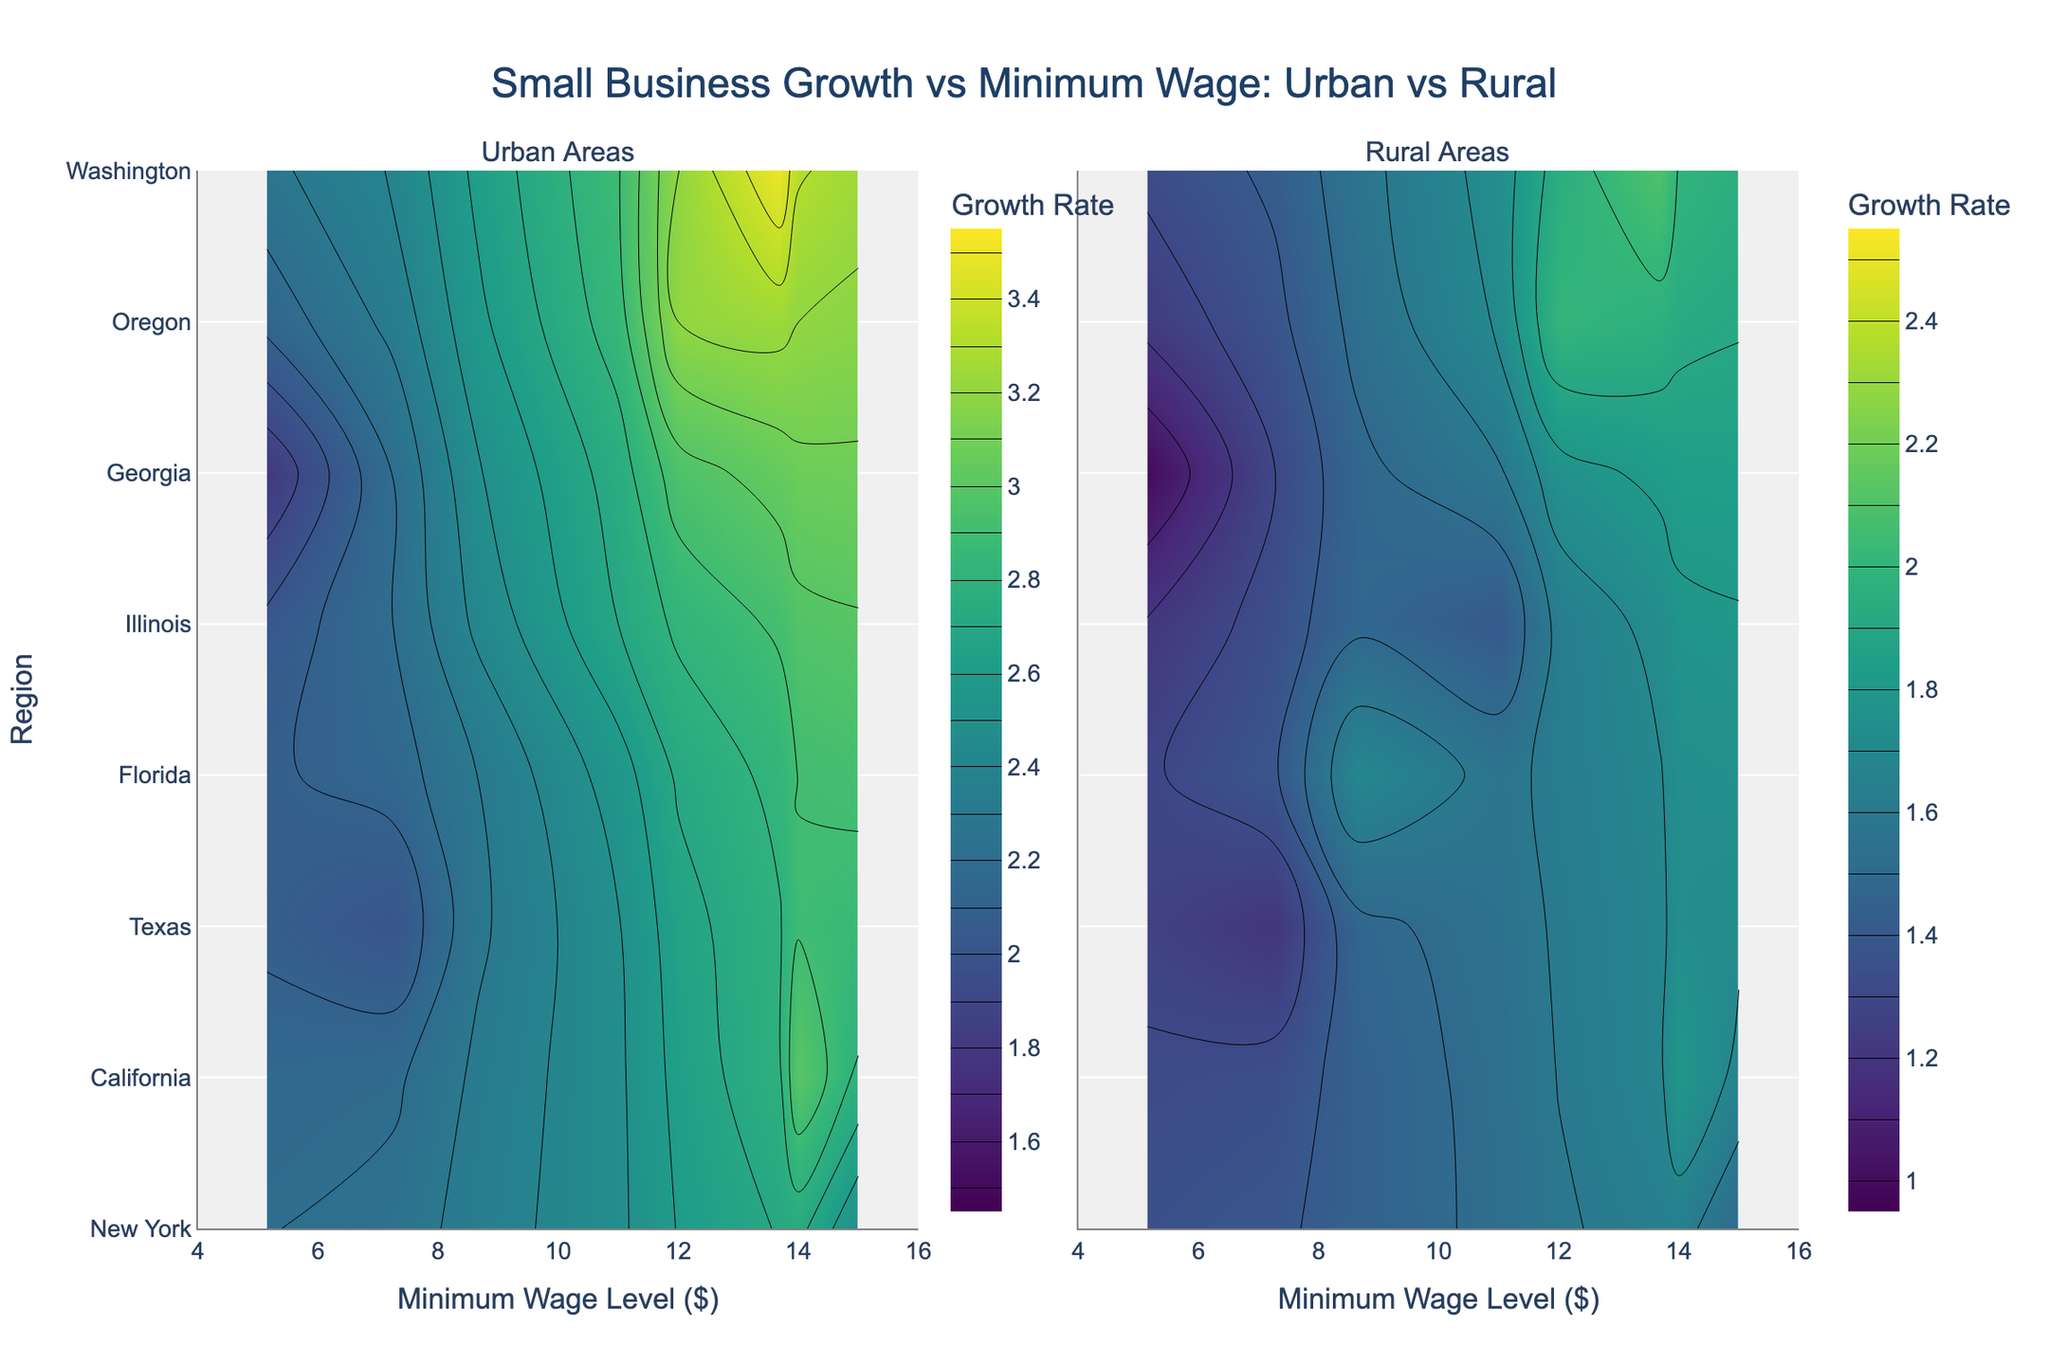What is the title of the figure? The title is located at the top center of the figure, visually distinguishing itself from the rest of the content and provides a summary of what the figure represents.
Answer: Small Business Growth vs Minimum Wage: Urban vs Rural What does the y-axis represent? The y-axis on both subplots lists different regions, as indicated by the labels along the vertical axis on the left side.
Answer: Region How many subplots are in the figure? The figure is divided into two separate parts side by side, indicating the usage of subplots.
Answer: Two Which region shows the highest growth in urban areas? To determine this, check the highest growth rate value among urban areas, which is indicated by the contour colors and labels.
Answer: Washington What is the range of minimum wage levels shown in this figure? The minimum wage levels are represented along the x-axis, and the range can be determined by noting the lowest and highest values.
Answer: $5.15 to $15 Is the growth in rural areas generally higher or lower than in urban areas? Comparing the general height of contour levels between the two subplots provides insight into this question.
Answer: Lower Which region has the smallest business growth rate in rural areas? The rural subplot shows the contour with the lowest growth rate, which is listed near a specific region.
Answer: Georgia How does the small business growth in New York's urban area compare to its rural area? By comparing the contours for New York in both subplots, differences in growth between urban and rural areas can be assessed.
Answer: New York's urban (2.5) is higher than rural (1.5) What's the difference in small business growth between urban and rural areas in California? Identify the growth rates for California in both subplots and subtract the rural value from the urban value.
Answer: 1.2 (3.0 - 1.8) Which area type shows more variation in small business growth rates? By observing the spread and variation in contour levels across both subplots, the variation in each area type can be inferred.
Answer: Urban Areas 